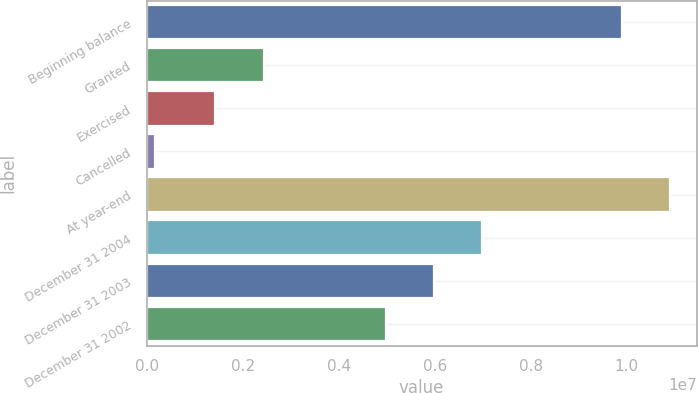Convert chart. <chart><loc_0><loc_0><loc_500><loc_500><bar_chart><fcel>Beginning balance<fcel>Granted<fcel>Exercised<fcel>Cancelled<fcel>At year-end<fcel>December 31 2004<fcel>December 31 2003<fcel>December 31 2002<nl><fcel>9.90527e+06<fcel>2.43505e+06<fcel>1.43119e+06<fcel>167183<fcel>1.09091e+07<fcel>6.9839e+06<fcel>5.98003e+06<fcel>4.97617e+06<nl></chart> 